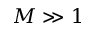Convert formula to latex. <formula><loc_0><loc_0><loc_500><loc_500>M \gg 1</formula> 